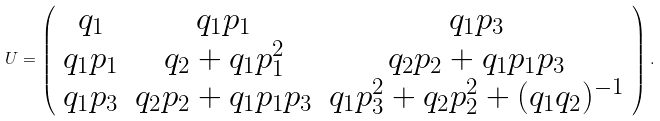Convert formula to latex. <formula><loc_0><loc_0><loc_500><loc_500>U = \left ( \begin{array} { c c c } q _ { 1 } & q _ { 1 } p _ { 1 } & q _ { 1 } p _ { 3 } \\ q _ { 1 } p _ { 1 } & q _ { 2 } + q _ { 1 } p _ { 1 } ^ { 2 } & q _ { 2 } p _ { 2 } + q _ { 1 } p _ { 1 } p _ { 3 } \\ q _ { 1 } p _ { 3 } & q _ { 2 } p _ { 2 } + q _ { 1 } p _ { 1 } p _ { 3 } & q _ { 1 } p _ { 3 } ^ { 2 } + q _ { 2 } p _ { 2 } ^ { 2 } + ( q _ { 1 } q _ { 2 } ) ^ { - 1 } \\ \end{array} \right ) .</formula> 